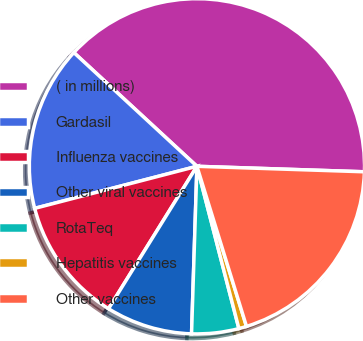Convert chart to OTSL. <chart><loc_0><loc_0><loc_500><loc_500><pie_chart><fcel>( in millions)<fcel>Gardasil<fcel>Influenza vaccines<fcel>Other viral vaccines<fcel>RotaTeq<fcel>Hepatitis vaccines<fcel>Other vaccines<nl><fcel>38.65%<fcel>15.91%<fcel>12.12%<fcel>8.33%<fcel>4.54%<fcel>0.75%<fcel>19.7%<nl></chart> 